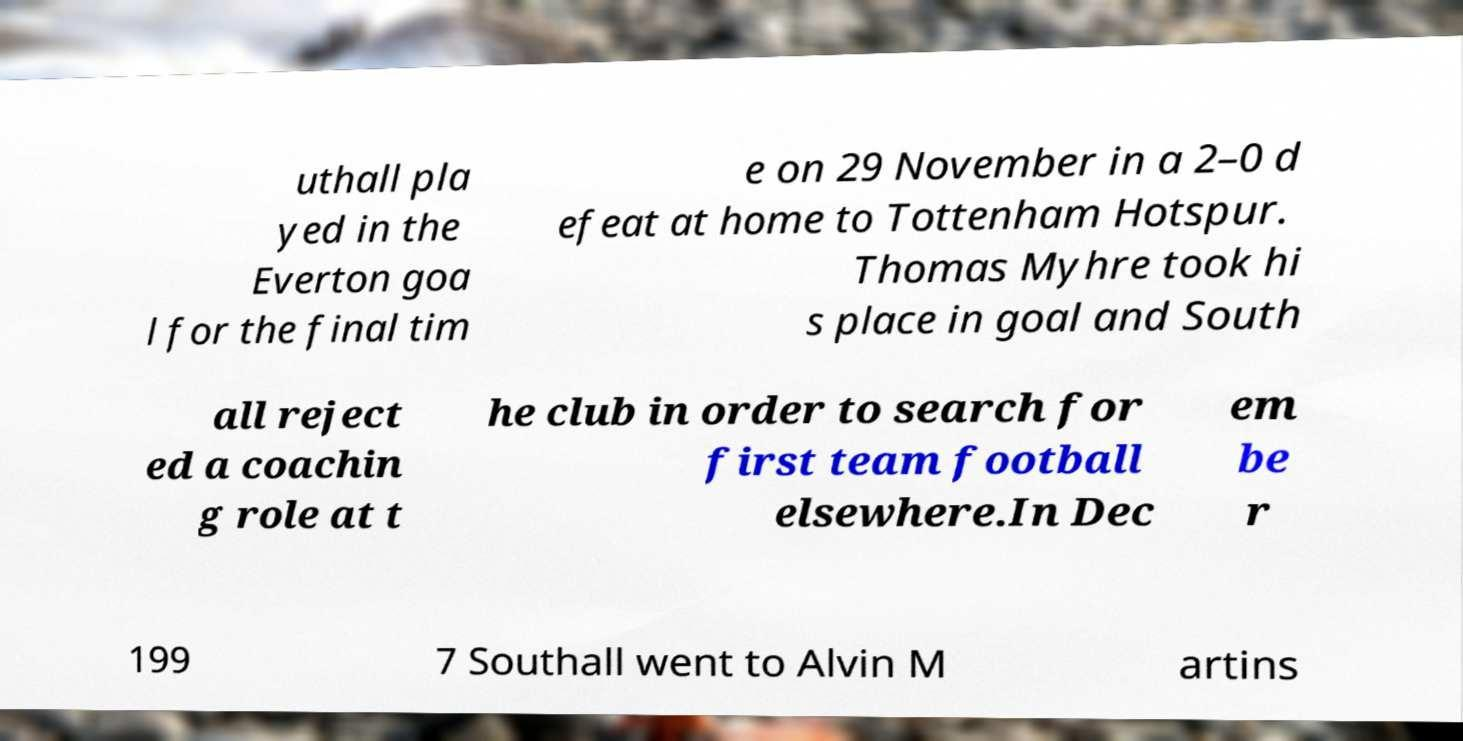Can you read and provide the text displayed in the image?This photo seems to have some interesting text. Can you extract and type it out for me? uthall pla yed in the Everton goa l for the final tim e on 29 November in a 2–0 d efeat at home to Tottenham Hotspur. Thomas Myhre took hi s place in goal and South all reject ed a coachin g role at t he club in order to search for first team football elsewhere.In Dec em be r 199 7 Southall went to Alvin M artins 